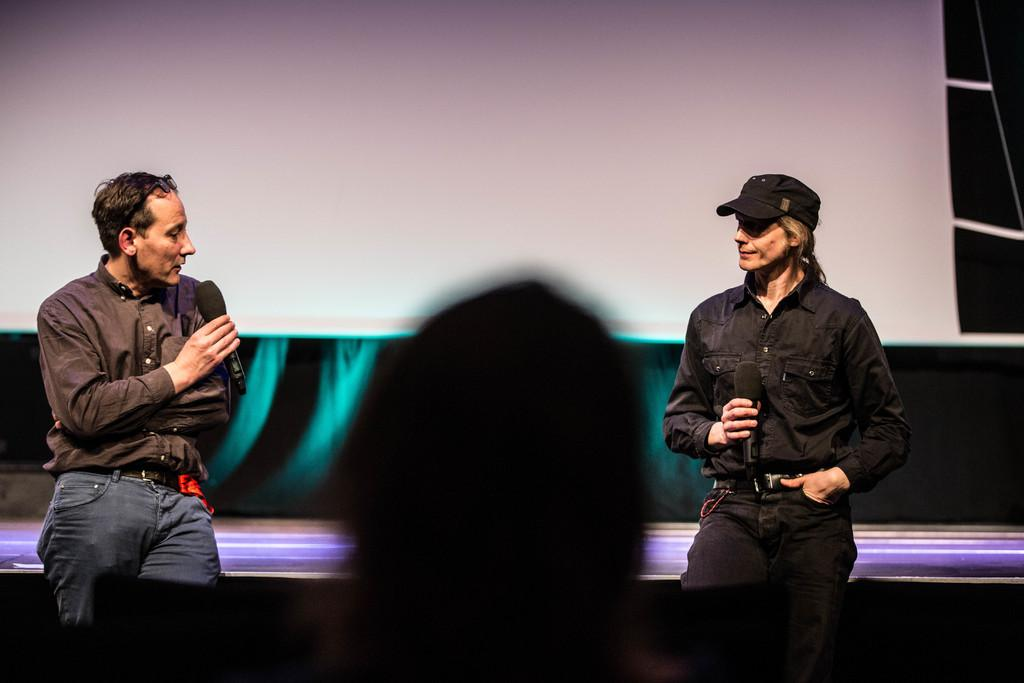How many men are visible in the image? There are two men visible in the image, one on the right side and one on the left side. Can you describe the positioning of the men in the image? One man is on the right side and the other is on the left side of the image. What color is the sheet that the man on the left side of the image is holding? There is no sheet present in the image, and therefore no color can be determined. 